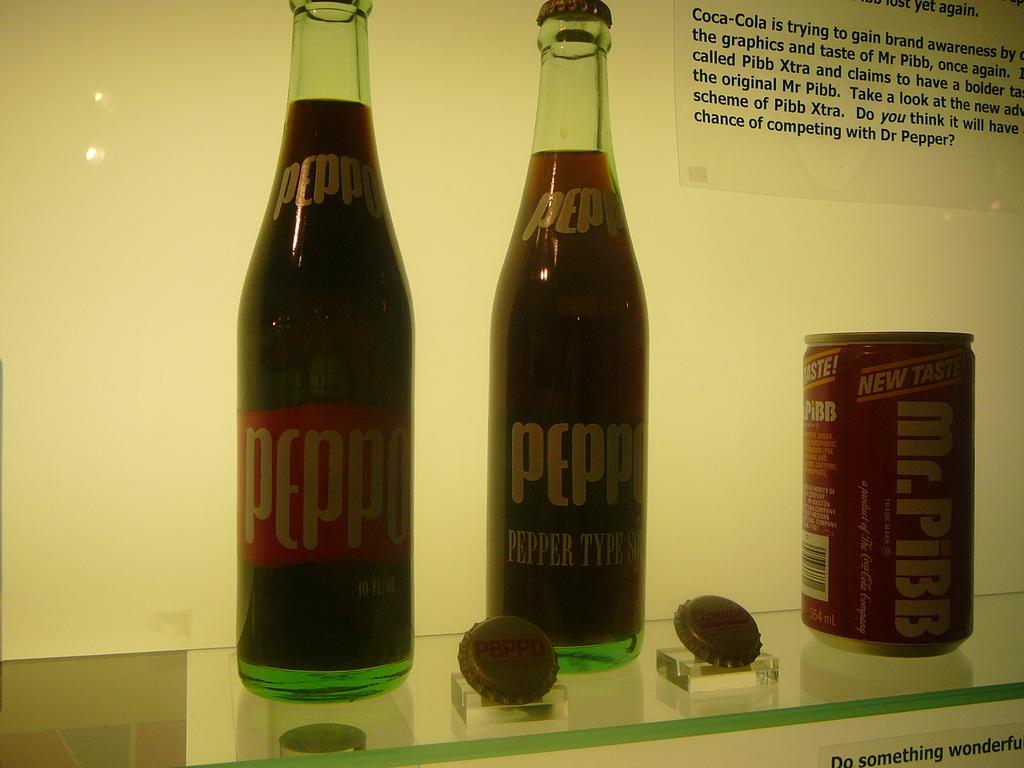What brand of soda has a, "new taste"?
Your response must be concise. Mr. pibb. What is the name on the first bottle?
Provide a short and direct response. Peppo. 